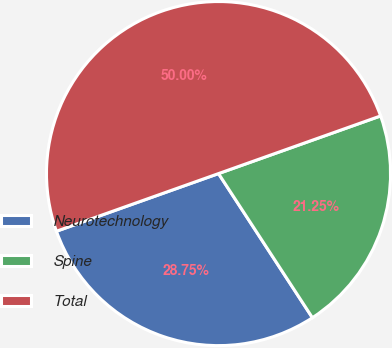<chart> <loc_0><loc_0><loc_500><loc_500><pie_chart><fcel>Neurotechnology<fcel>Spine<fcel>Total<nl><fcel>28.75%<fcel>21.25%<fcel>50.0%<nl></chart> 